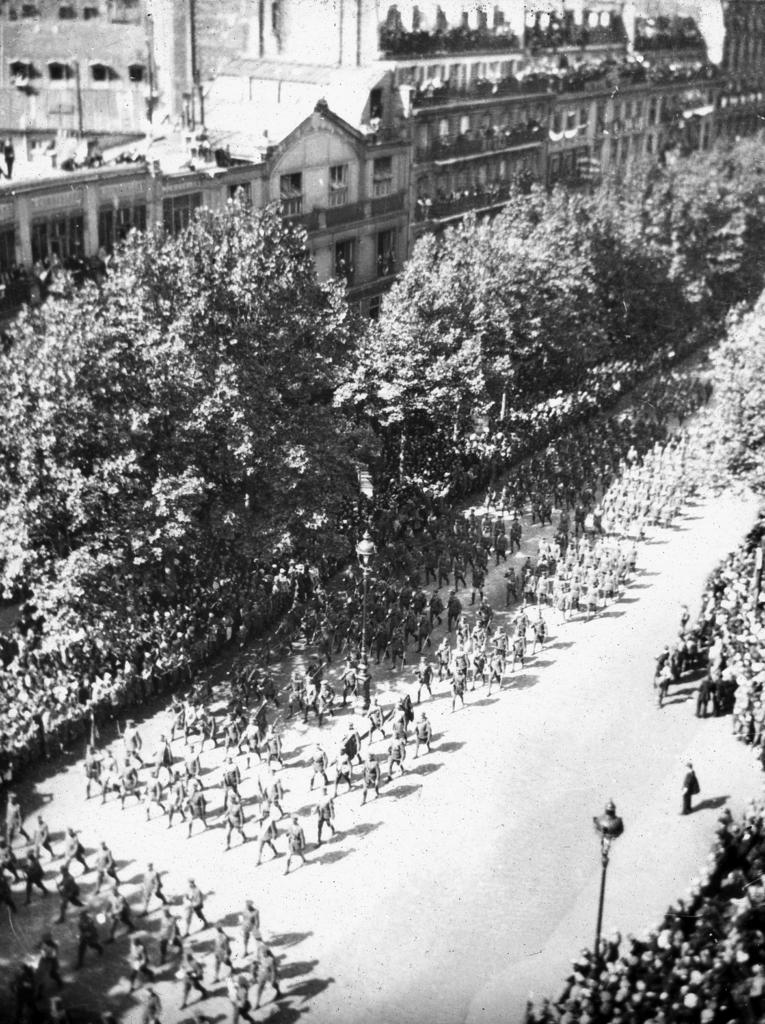What type of structures are visible in the image? There are buildings in the image. What else can be seen in the image besides buildings? There are trees and groups of people walking on the road in the image. Are there any other people in the image? Yes, there are also groups of people standing in the image. What type of lighting is present in the image? There are street lights in the image. What type of scent can be detected from the soup in the image? There is no soup present in the image, so it is not possible to detect any scent. 